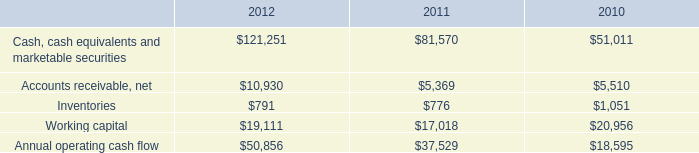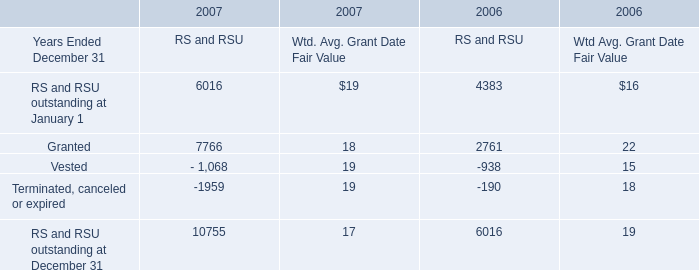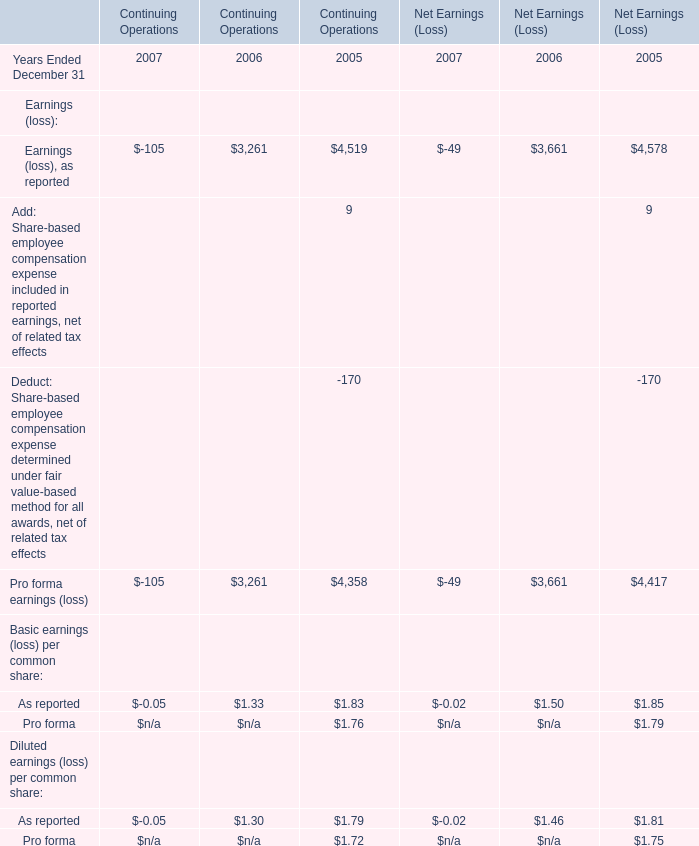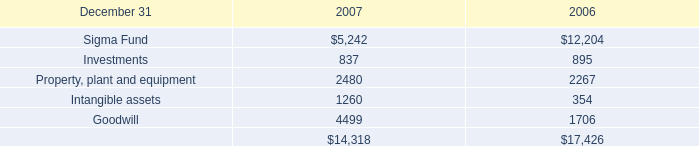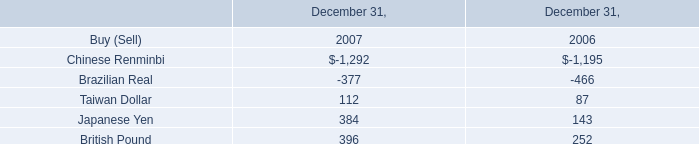In the year with the most Vested, what is the growth rate of Granted for RS and RSU? 
Computations: ((7766 - 2761) / 2761)
Answer: 1.81275. 